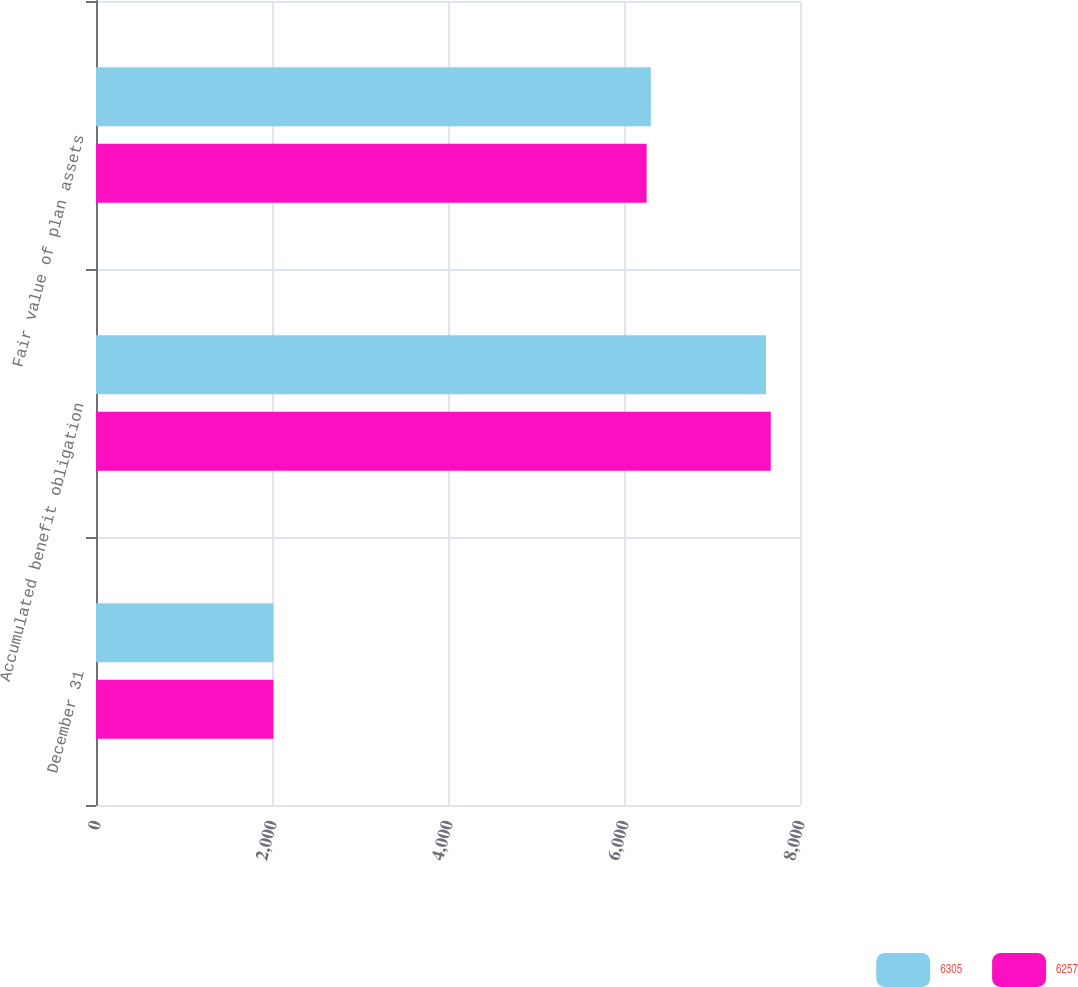<chart> <loc_0><loc_0><loc_500><loc_500><stacked_bar_chart><ecel><fcel>December 31<fcel>Accumulated benefit obligation<fcel>Fair value of plan assets<nl><fcel>6305<fcel>2017<fcel>7614<fcel>6305<nl><fcel>6257<fcel>2016<fcel>7668<fcel>6257<nl></chart> 